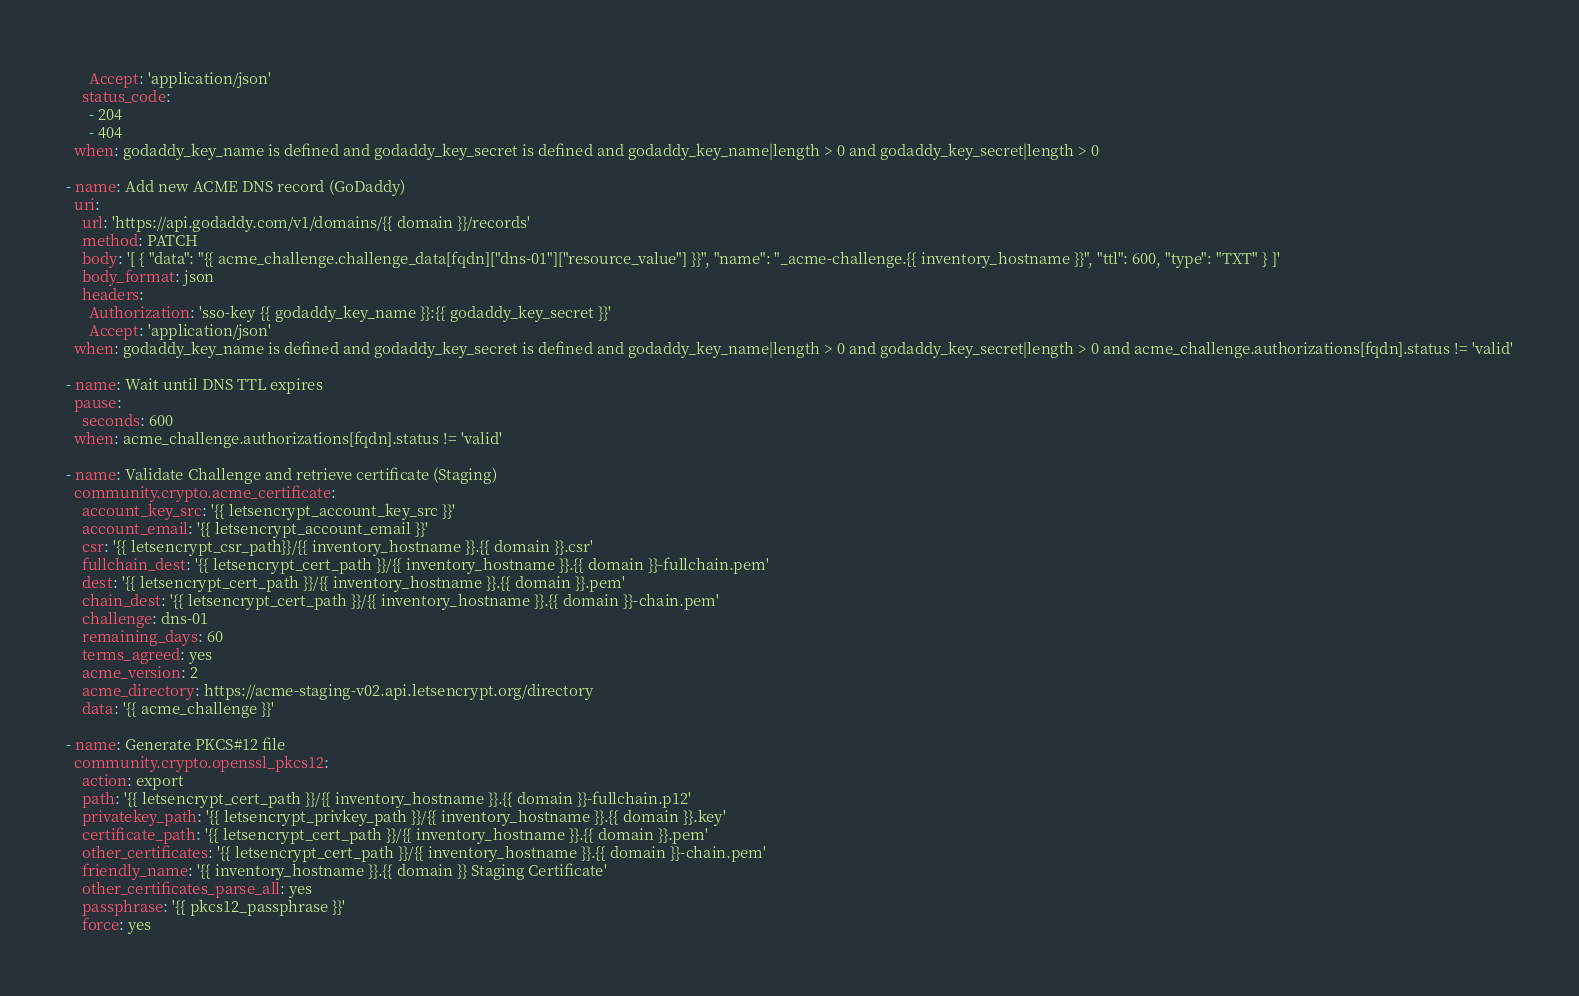<code> <loc_0><loc_0><loc_500><loc_500><_YAML_>      Accept: 'application/json'
    status_code: 
      - 204
      - 404
  when: godaddy_key_name is defined and godaddy_key_secret is defined and godaddy_key_name|length > 0 and godaddy_key_secret|length > 0 

- name: Add new ACME DNS record (GoDaddy)
  uri:
    url: 'https://api.godaddy.com/v1/domains/{{ domain }}/records'
    method: PATCH
    body: '[ { "data": "{{ acme_challenge.challenge_data[fqdn]["dns-01"]["resource_value"] }}", "name": "_acme-challenge.{{ inventory_hostname }}", "ttl": 600, "type": "TXT" } ]'
    body_format: json
    headers:
      Authorization: 'sso-key {{ godaddy_key_name }}:{{ godaddy_key_secret }}'
      Accept: 'application/json'
  when: godaddy_key_name is defined and godaddy_key_secret is defined and godaddy_key_name|length > 0 and godaddy_key_secret|length > 0 and acme_challenge.authorizations[fqdn].status != 'valid'

- name: Wait until DNS TTL expires
  pause:
    seconds: 600
  when: acme_challenge.authorizations[fqdn].status != 'valid'

- name: Validate Challenge and retrieve certificate (Staging)
  community.crypto.acme_certificate:
    account_key_src: '{{ letsencrypt_account_key_src }}'
    account_email: '{{ letsencrypt_account_email }}'
    csr: '{{ letsencrypt_csr_path}}/{{ inventory_hostname }}.{{ domain }}.csr'
    fullchain_dest: '{{ letsencrypt_cert_path }}/{{ inventory_hostname }}.{{ domain }}-fullchain.pem'
    dest: '{{ letsencrypt_cert_path }}/{{ inventory_hostname }}.{{ domain }}.pem'
    chain_dest: '{{ letsencrypt_cert_path }}/{{ inventory_hostname }}.{{ domain }}-chain.pem'
    challenge: dns-01
    remaining_days: 60
    terms_agreed: yes
    acme_version: 2
    acme_directory: https://acme-staging-v02.api.letsencrypt.org/directory
    data: '{{ acme_challenge }}'

- name: Generate PKCS#12 file
  community.crypto.openssl_pkcs12:
    action: export
    path: '{{ letsencrypt_cert_path }}/{{ inventory_hostname }}.{{ domain }}-fullchain.p12'
    privatekey_path: '{{ letsencrypt_privkey_path }}/{{ inventory_hostname }}.{{ domain }}.key'
    certificate_path: '{{ letsencrypt_cert_path }}/{{ inventory_hostname }}.{{ domain }}.pem'
    other_certificates: '{{ letsencrypt_cert_path }}/{{ inventory_hostname }}.{{ domain }}-chain.pem'
    friendly_name: '{{ inventory_hostname }}.{{ domain }} Staging Certificate'
    other_certificates_parse_all: yes
    passphrase: '{{ pkcs12_passphrase }}'
    force: yes
</code> 